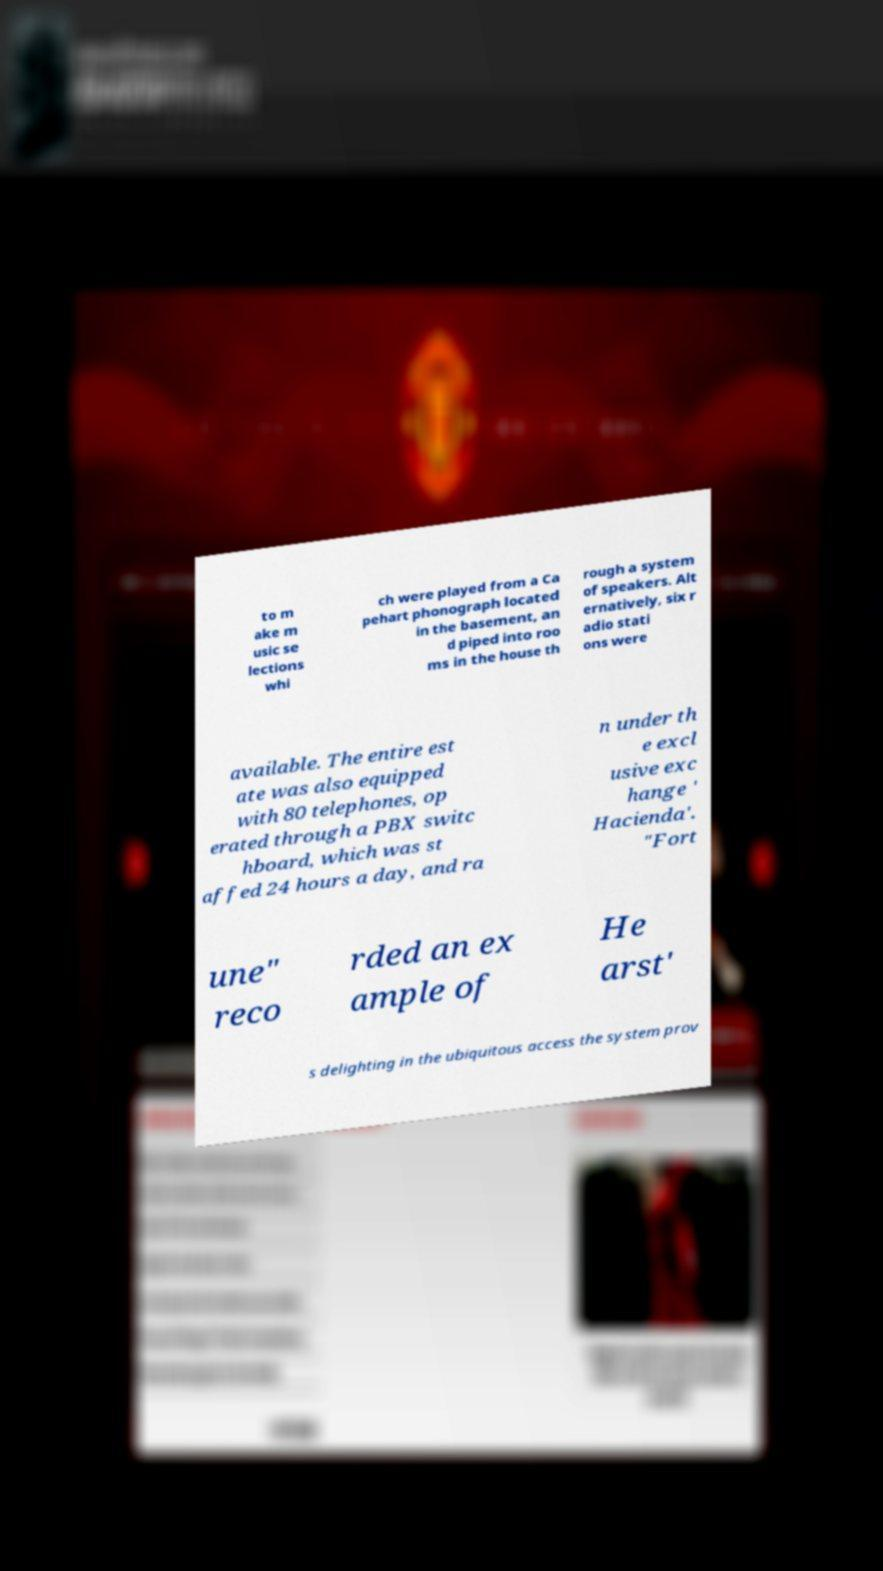There's text embedded in this image that I need extracted. Can you transcribe it verbatim? to m ake m usic se lections whi ch were played from a Ca pehart phonograph located in the basement, an d piped into roo ms in the house th rough a system of speakers. Alt ernatively, six r adio stati ons were available. The entire est ate was also equipped with 80 telephones, op erated through a PBX switc hboard, which was st affed 24 hours a day, and ra n under th e excl usive exc hange ' Hacienda'. "Fort une" reco rded an ex ample of He arst' s delighting in the ubiquitous access the system prov 